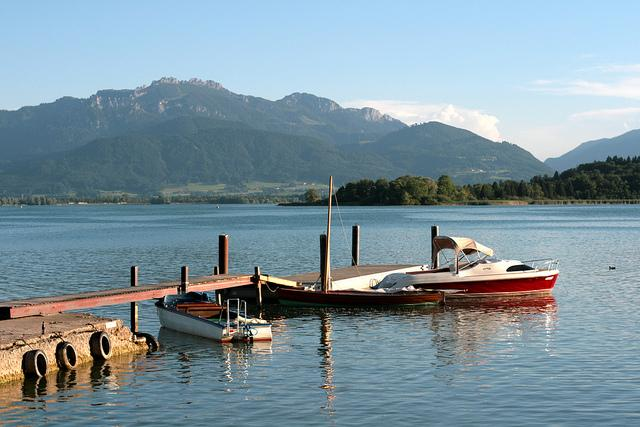What is the name of the platform used to walk out on the water? pier 